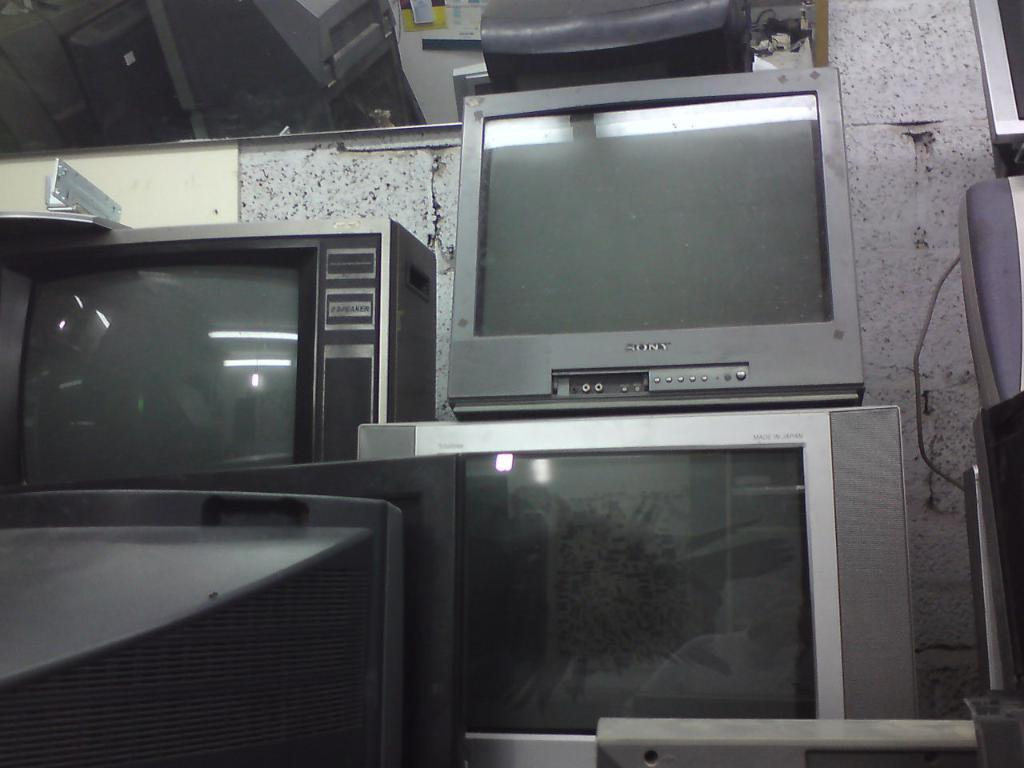<image>
Offer a succinct explanation of the picture presented. A shop filled with stacked tvs and a gray Sony brand tv on top of another tv 